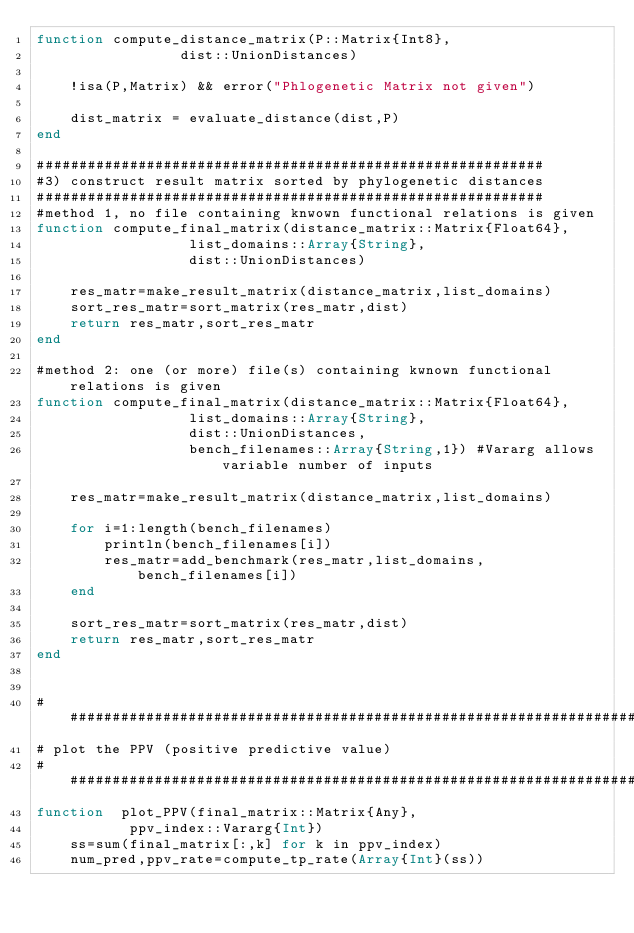Convert code to text. <code><loc_0><loc_0><loc_500><loc_500><_Julia_>function compute_distance_matrix(P::Matrix{Int8},
				 dist::UnionDistances)

	!isa(P,Matrix) && error("Phlogenetic Matrix not given")

	dist_matrix = evaluate_distance(dist,P)
end

############################################################
#3) construct result matrix sorted by phylogenetic distances 
############################################################
#method 1, no file containing knwown functional relations is given
function compute_final_matrix(distance_matrix::Matrix{Float64},
			      list_domains::Array{String},
			      dist::UnionDistances)

	res_matr=make_result_matrix(distance_matrix,list_domains)
	sort_res_matr=sort_matrix(res_matr,dist)
	return res_matr,sort_res_matr
end

#method 2: one (or more) file(s) containing kwnown functional relations is given
function compute_final_matrix(distance_matrix::Matrix{Float64},
			      list_domains::Array{String},
			      dist::UnionDistances,
                  bench_filenames::Array{String,1}) #Vararg allows variable number of inputs

	res_matr=make_result_matrix(distance_matrix,list_domains)

	for i=1:length(bench_filenames)
		println(bench_filenames[i])
		res_matr=add_benchmark(res_matr,list_domains,bench_filenames[i])
	end

	sort_res_matr=sort_matrix(res_matr,dist)
	return res_matr,sort_res_matr
end


######################################################################
# plot the PPV (positive predictive value)
######################################################################
function  plot_PPV(final_matrix::Matrix{Any},
		   ppv_index::Vararg{Int})
	ss=sum(final_matrix[:,k] for k in ppv_index)
	num_pred,ppv_rate=compute_tp_rate(Array{Int}(ss))</code> 